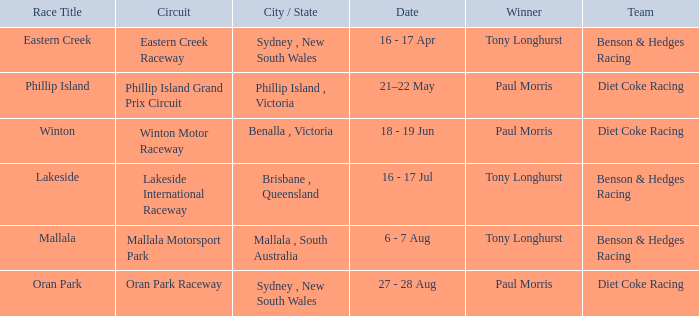Which driver won the Phillip Island Grand Prix Circuit? Paul Morris. 